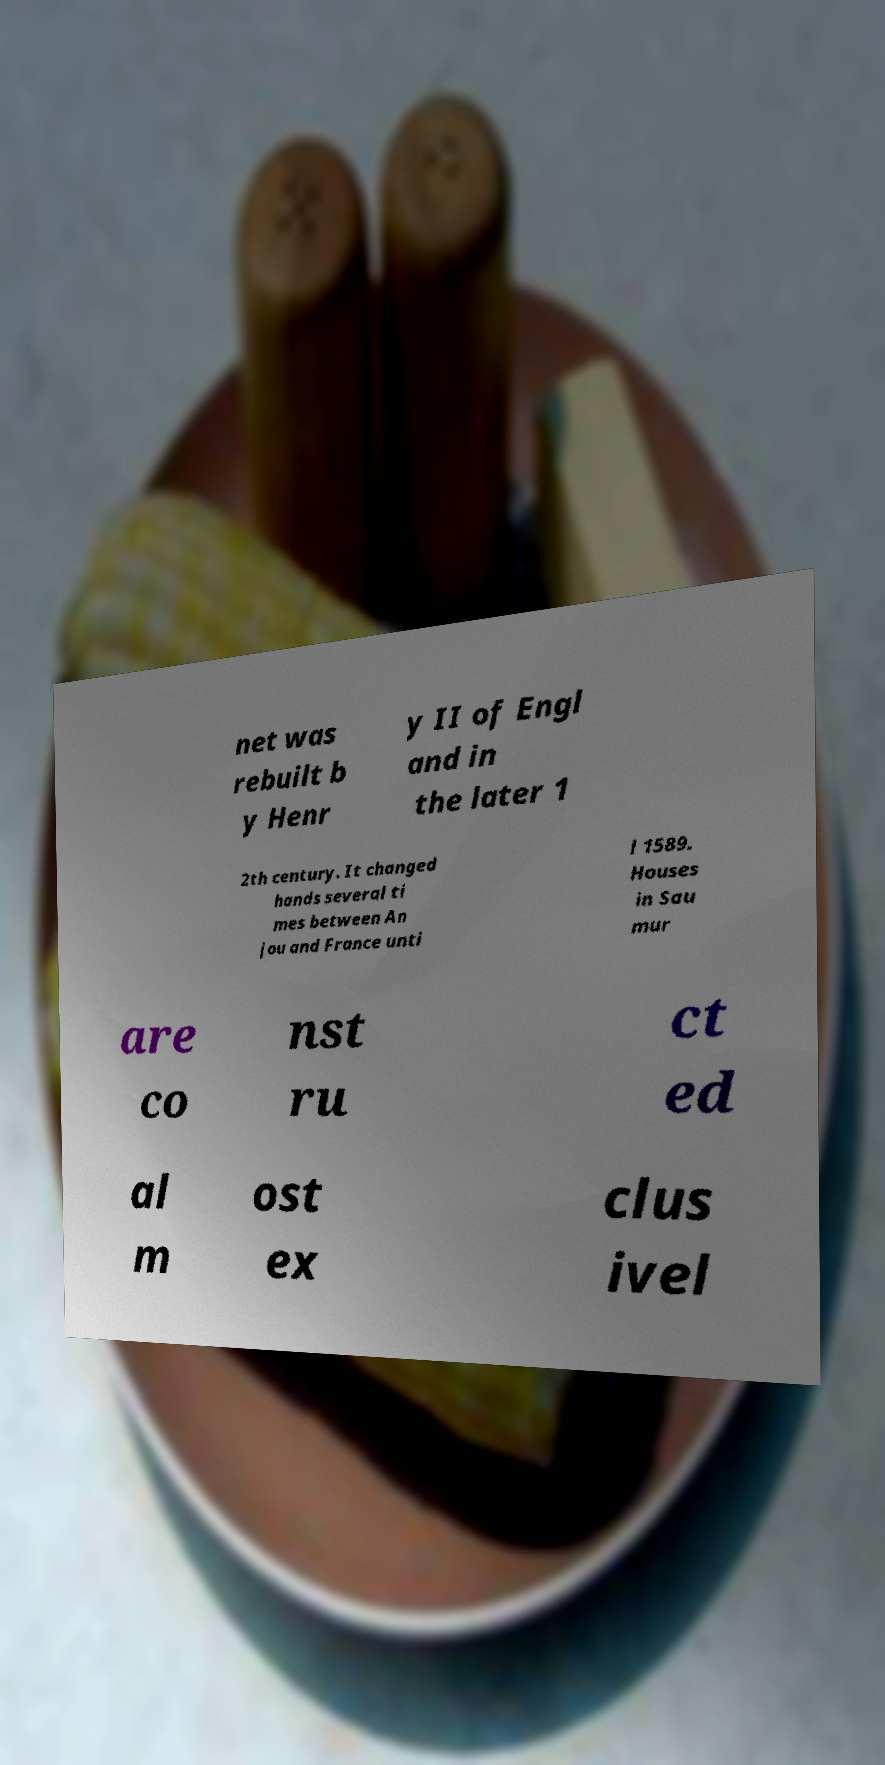Could you assist in decoding the text presented in this image and type it out clearly? net was rebuilt b y Henr y II of Engl and in the later 1 2th century. It changed hands several ti mes between An jou and France unti l 1589. Houses in Sau mur are co nst ru ct ed al m ost ex clus ivel 